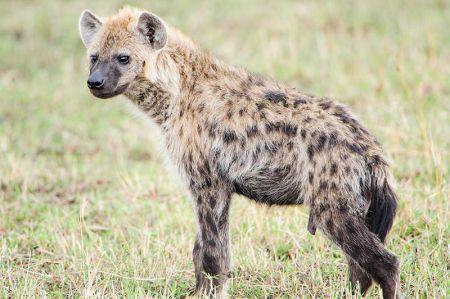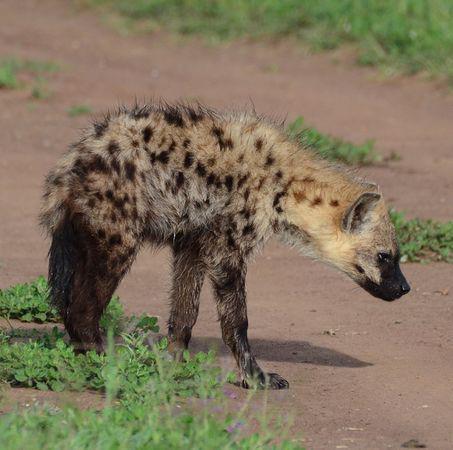The first image is the image on the left, the second image is the image on the right. Given the left and right images, does the statement "There are two hyenas in a photo." hold true? Answer yes or no. No. 